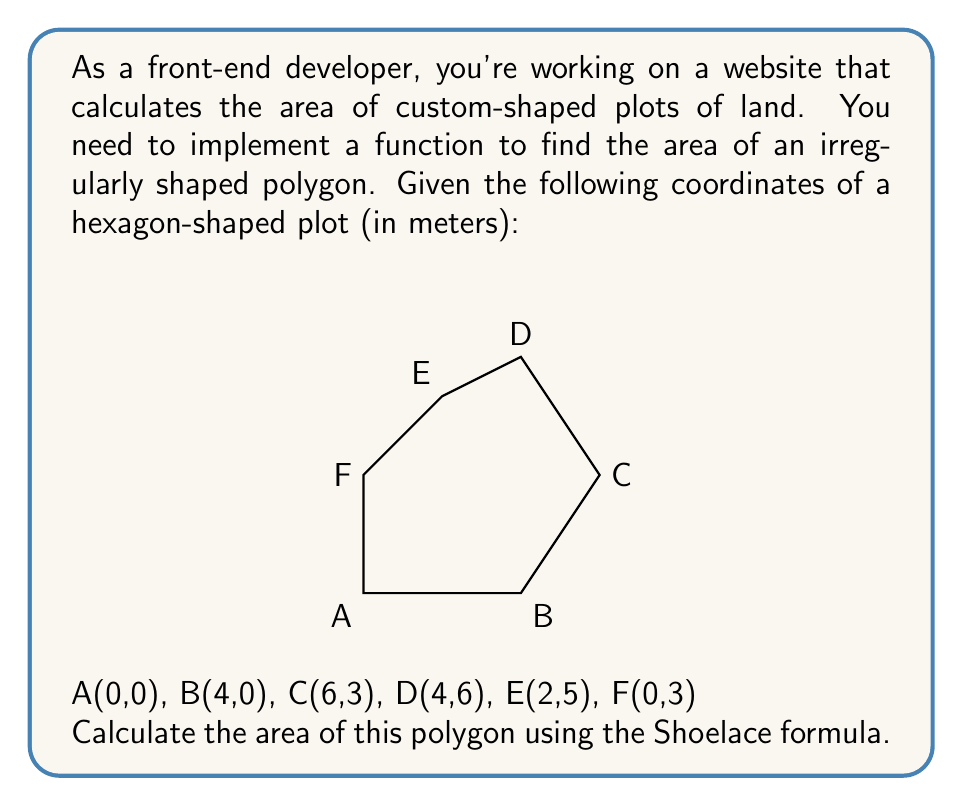Can you answer this question? To find the area of an irregularly shaped polygon, we can use the Shoelace formula (also known as the surveyor's formula). The formula is:

$$ \text{Area} = \frac{1}{2}\left|\sum_{i=1}^{n-1} (x_i y_{i+1} + x_n y_1) - \sum_{i=1}^{n-1} (y_i x_{i+1} + y_n x_1)\right| $$

Where $(x_i, y_i)$ are the coordinates of the $i$-th vertex.

Let's apply this formula to our hexagon:

1. First, let's list out our coordinates in order:
   $(x_1, y_1) = (0, 0)$
   $(x_2, y_2) = (4, 0)$
   $(x_3, y_3) = (6, 3)$
   $(x_4, y_4) = (4, 6)$
   $(x_5, y_5) = (2, 5)$
   $(x_6, y_6) = (0, 3)$

2. Now, let's calculate the first sum:
   $\sum_{i=1}^{n-1} (x_i y_{i+1} + x_n y_1) = (0 \cdot 0 + 4 \cdot 3 + 6 \cdot 6 + 4 \cdot 5 + 2 \cdot 3 + 0 \cdot 0) = 12 + 36 + 20 + 6 = 74$

3. Calculate the second sum:
   $\sum_{i=1}^{n-1} (y_i x_{i+1} + y_n x_1) = (0 \cdot 4 + 0 \cdot 6 + 3 \cdot 4 + 6 \cdot 2 + 5 \cdot 0 + 3 \cdot 0) = 12 + 12 = 24$

4. Subtract the second sum from the first:
   $74 - 24 = 50$

5. Take the absolute value (which doesn't change anything in this case) and divide by 2:
   $\frac{1}{2} |50| = 25$

Therefore, the area of the hexagon is 25 square meters.
Answer: 25 m² 